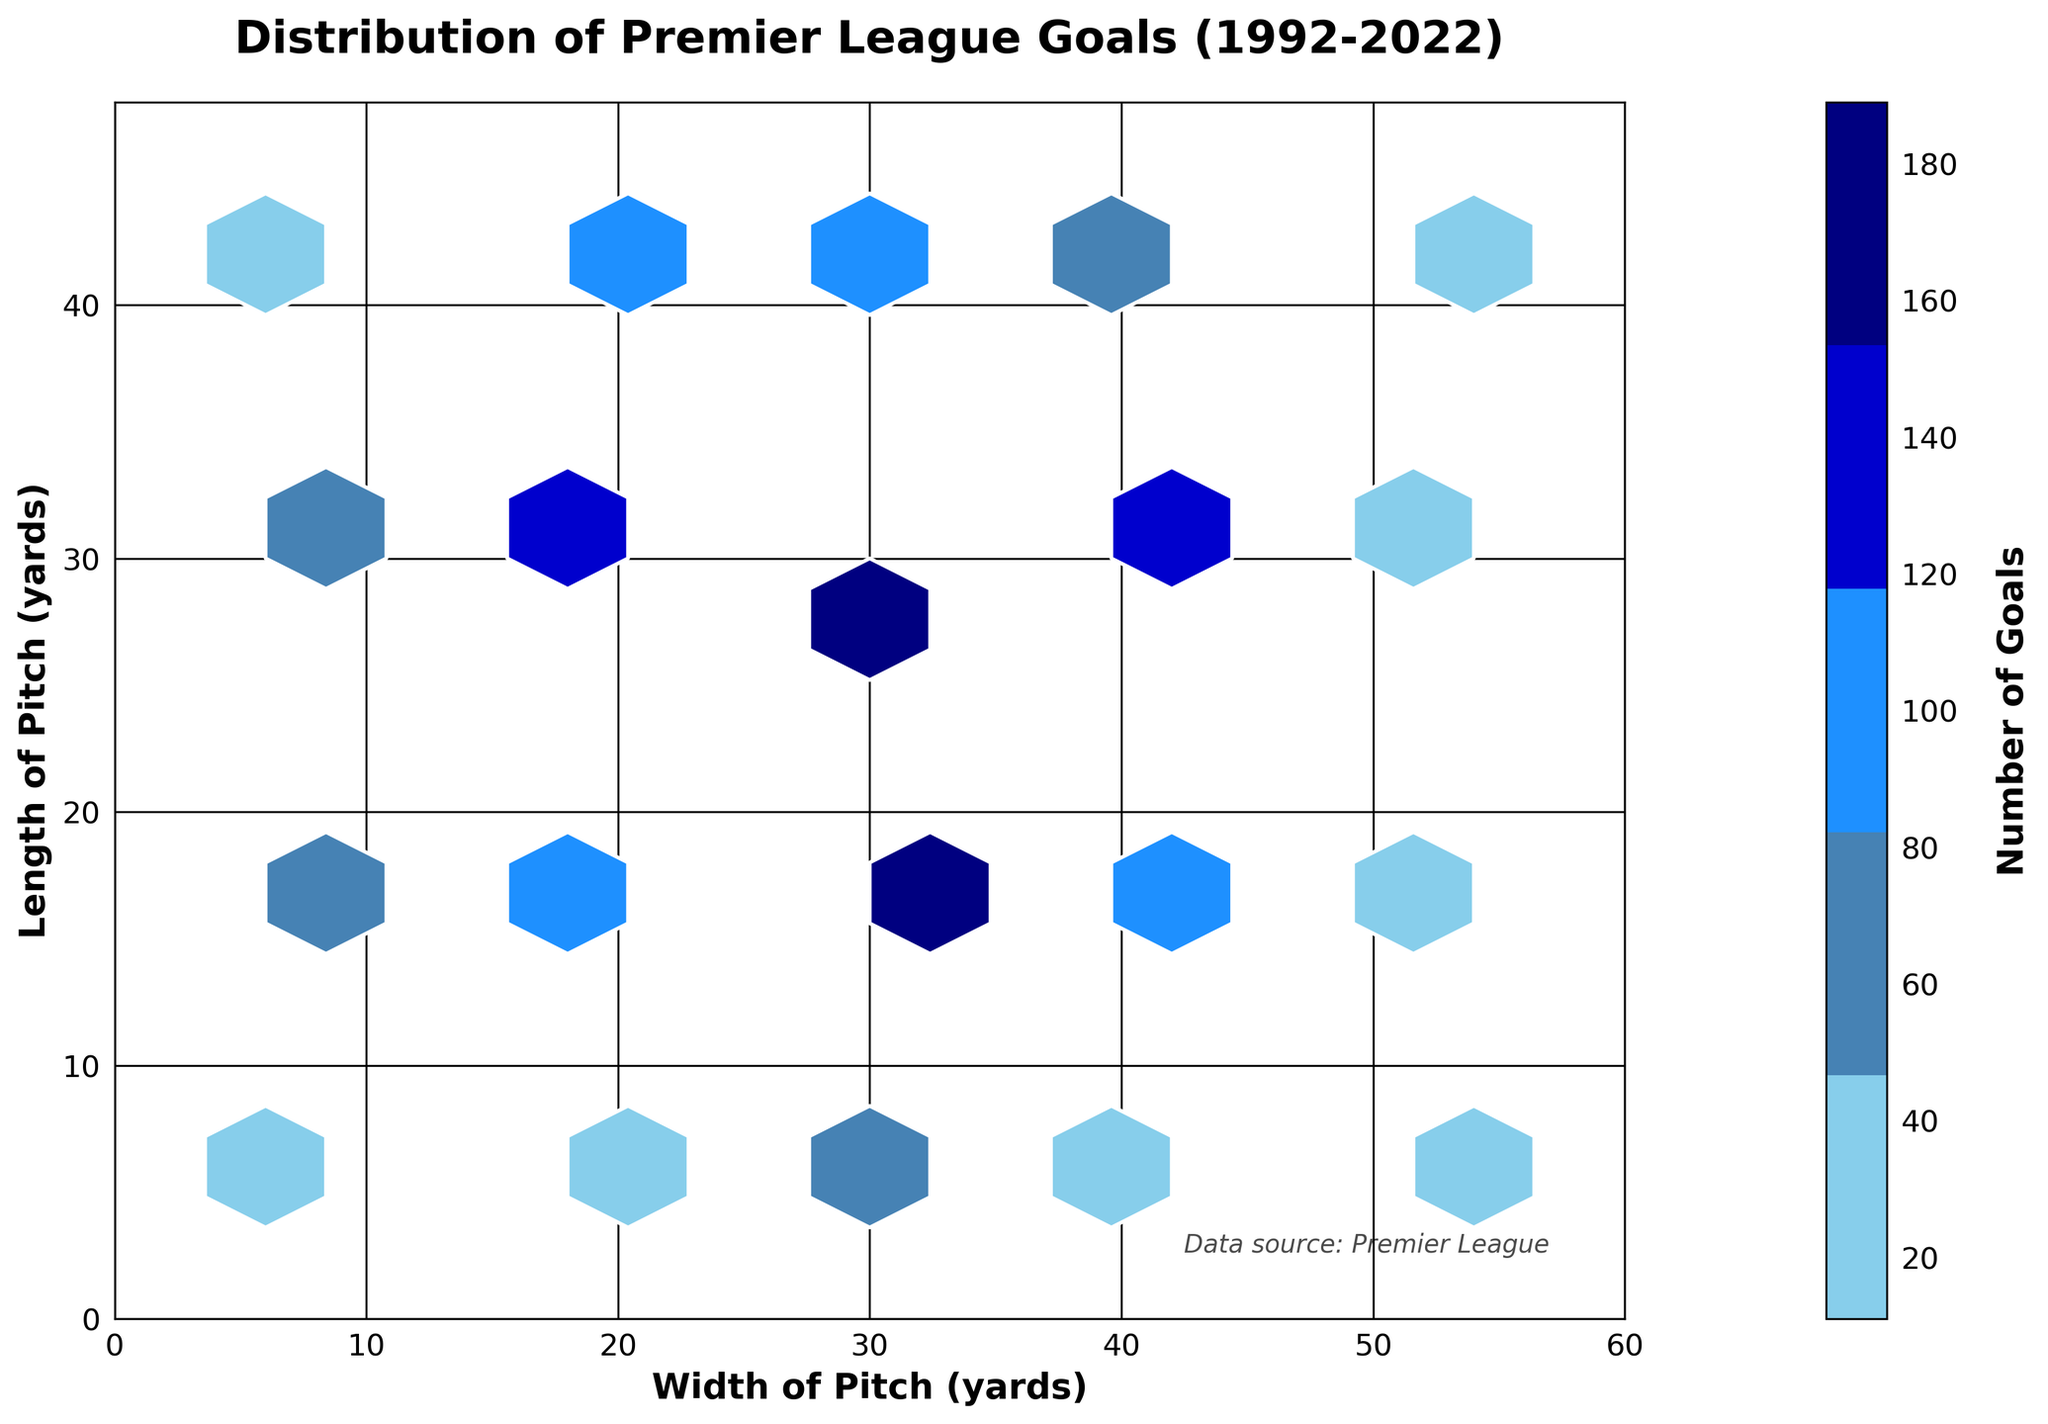What is the title of the hexbin plot? The title of the hexbin plot is positioned at the top of the figure. It provides a summary of what the plot represents. In this case, it should be read from the title text displayed.
Answer: "Distribution of Premier League Goals (1992-2022)" What is the maximum color intensity on the colorbar? The most intense color on the colorbar corresponds to the highest number of goals scored in any hexbin. By checking the topmost value on the colorbar, you can determine this maximum value.
Answer: 200 Which pitch area has the highest number of goals scored? To identify the pitch area with the highest number of goals, observe the hexbin with the darkest color, then check its coordinates from the plot. The darkest hex represents the highest count.
Answer: (30, 30) Between the top half (y > 24) and bottom half (y ≤ 24) of the pitch, which area has more frequent goal-scoring? Compare the density and color intensity of hexbins in the top and bottom halves. The bottom half appears to have more darkly colored hexbins.
Answer: Bottom half (y ≤ 24) How many distinct grid sizes are created by the hexbin plot in terms of frequency count? The colorbar indicates distinct color bins, each representing a range of goal frequencies. Count these distinct ranges to get the answer.
Answer: 5 Are there more goals scored near the center (x = 30, y = 30) or near the edges of the pitch? Observe the color intensity near the center coordinates (30, 30) and compare it to the hexes at the edges of the pitch. The central region has darker colors indicating higher goal frequency.
Answer: Near the center What pitch width shows the maximum density of goals scored across all lengths? Look at columns of hexbins across different width coordinates and compare their intensity. Identify the width coordinate with the maximum hex density.
Answer: 30 Which area of the pitch (width 18, 30 or 42) has more variability in goal counts? To determine variability, observe the spread and color intensity variations of the hexbins along different widths. The width with varying colors (light to dark blue) suggest higher variability.
Answer: 30 Which specific hexbin corresponds to the lowest goal count area? Find the hexbin with the lightest color, as it represents the lowest number of goals counted. Locate its coordinates.
Answer: (6, 6) How many hexbins have at least 100 goals scored? Count the number of hexbins whose color intensity indicates a goal count of 100 or more. This requires referring to the color levels on the colorbar.
Answer: 6 